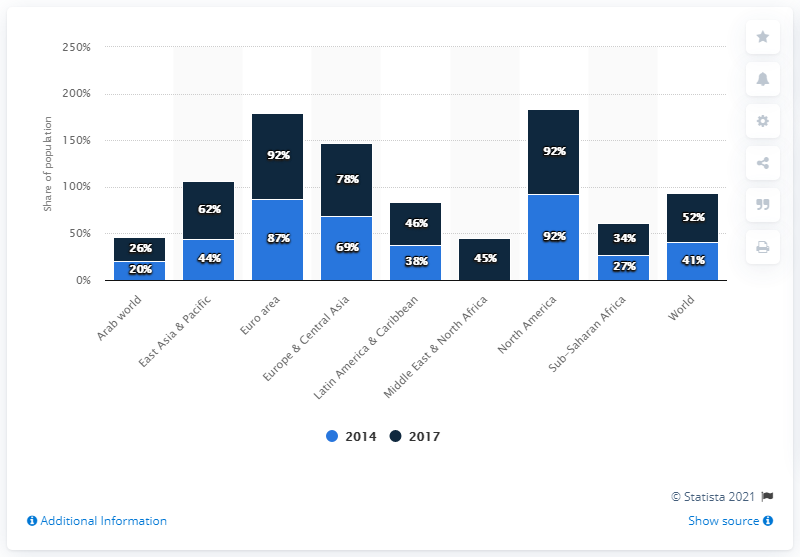Highlight a few significant elements in this photo. In 2014, the highest percentage of digital payments in North America was 87%. The Arab world has the region with the highest percentage of its population that made or received digital payments, at 46% of the total population. The percentage of the population in North America who made or received digital payments is 18.4%. In 2017, approximately 92% of people in North America made and/or received digital payments. 